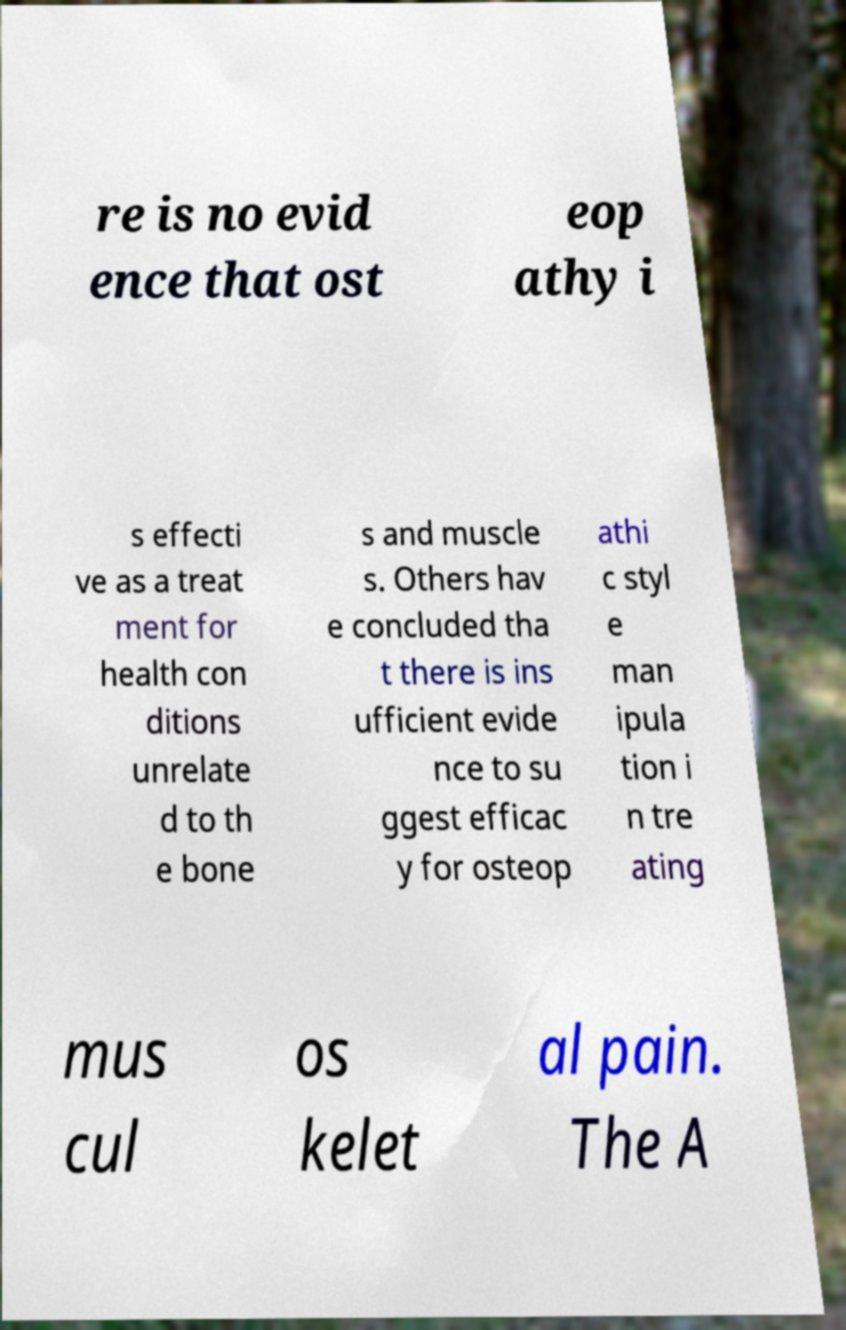Could you assist in decoding the text presented in this image and type it out clearly? re is no evid ence that ost eop athy i s effecti ve as a treat ment for health con ditions unrelate d to th e bone s and muscle s. Others hav e concluded tha t there is ins ufficient evide nce to su ggest efficac y for osteop athi c styl e man ipula tion i n tre ating mus cul os kelet al pain. The A 